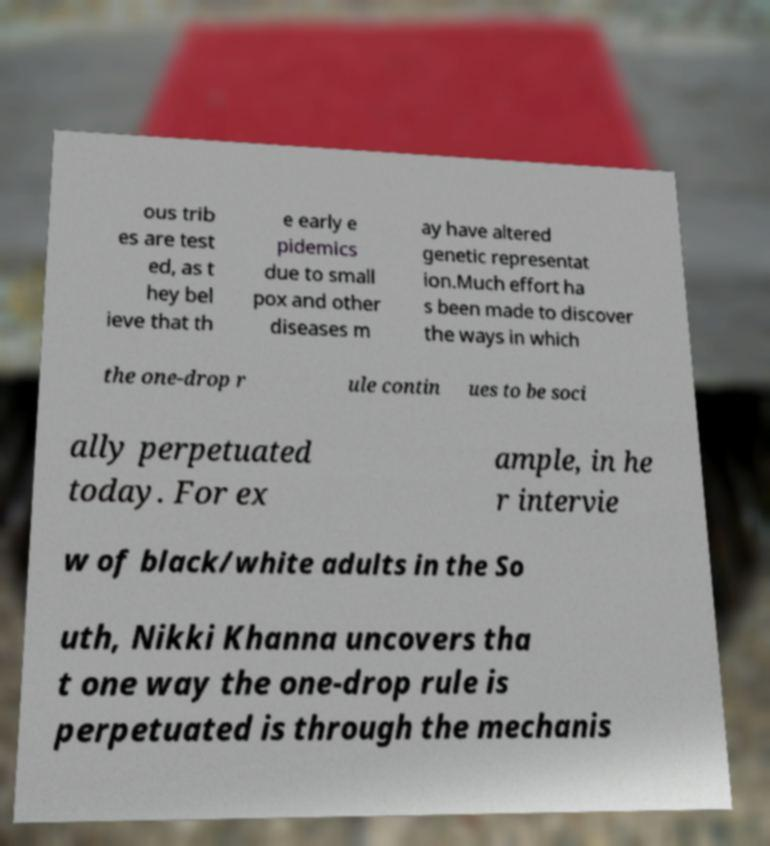What messages or text are displayed in this image? I need them in a readable, typed format. ous trib es are test ed, as t hey bel ieve that th e early e pidemics due to small pox and other diseases m ay have altered genetic representat ion.Much effort ha s been made to discover the ways in which the one-drop r ule contin ues to be soci ally perpetuated today. For ex ample, in he r intervie w of black/white adults in the So uth, Nikki Khanna uncovers tha t one way the one-drop rule is perpetuated is through the mechanis 